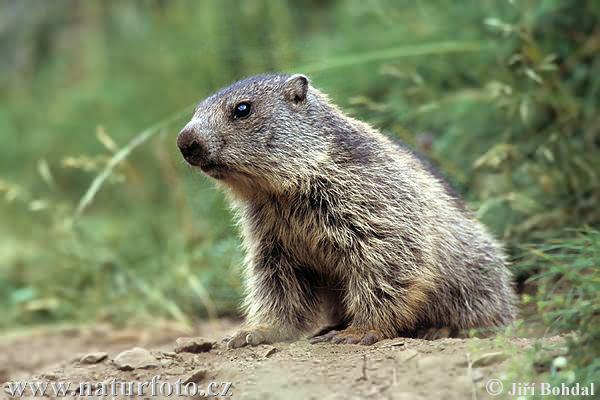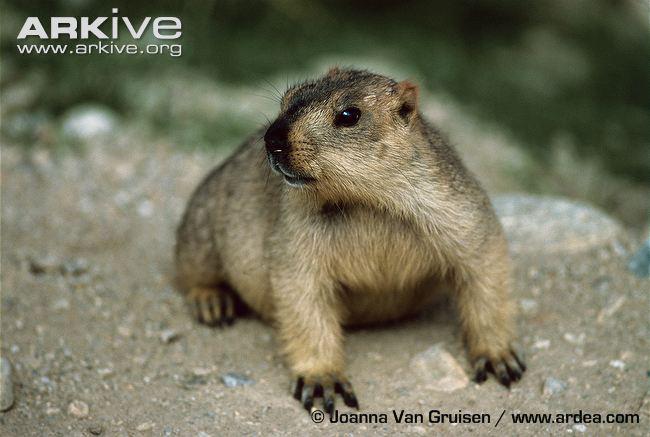The first image is the image on the left, the second image is the image on the right. For the images displayed, is the sentence "There are more animals in the image on the left." factually correct? Answer yes or no. No. The first image is the image on the left, the second image is the image on the right. Given the left and right images, does the statement "The combined images include at least two marmots with their heads raised and gazing leftward." hold true? Answer yes or no. Yes. 